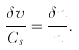<formula> <loc_0><loc_0><loc_500><loc_500>\frac { \delta v } { C _ { s } } = \frac { \delta n } { n } .</formula> 